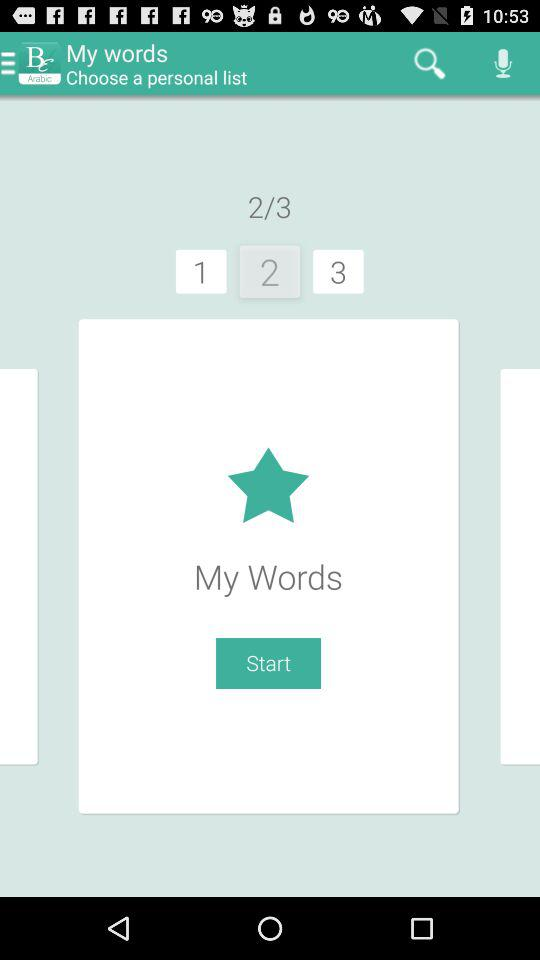Which list is currently selected? The currently selected list is "My Words". 